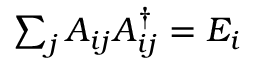Convert formula to latex. <formula><loc_0><loc_0><loc_500><loc_500>\sum _ { j } A _ { i j } A _ { i j } ^ { \dagger } = E _ { i }</formula> 